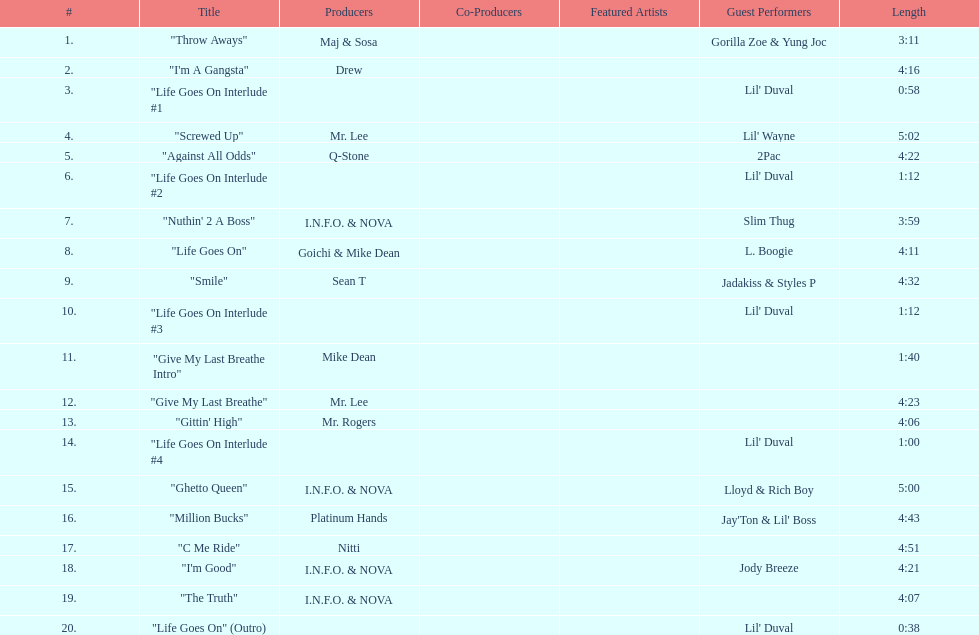How long is the longest track on the album? 5:02. 